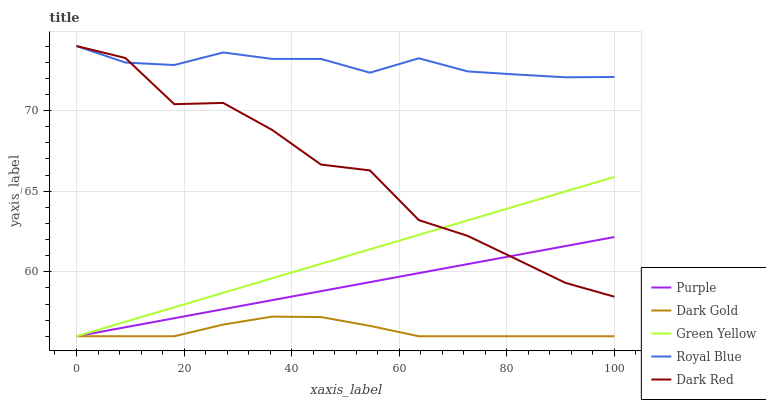Does Dark Gold have the minimum area under the curve?
Answer yes or no. Yes. Does Royal Blue have the maximum area under the curve?
Answer yes or no. Yes. Does Green Yellow have the minimum area under the curve?
Answer yes or no. No. Does Green Yellow have the maximum area under the curve?
Answer yes or no. No. Is Green Yellow the smoothest?
Answer yes or no. Yes. Is Dark Red the roughest?
Answer yes or no. Yes. Is Royal Blue the smoothest?
Answer yes or no. No. Is Royal Blue the roughest?
Answer yes or no. No. Does Purple have the lowest value?
Answer yes or no. Yes. Does Royal Blue have the lowest value?
Answer yes or no. No. Does Dark Red have the highest value?
Answer yes or no. Yes. Does Green Yellow have the highest value?
Answer yes or no. No. Is Dark Gold less than Royal Blue?
Answer yes or no. Yes. Is Dark Red greater than Dark Gold?
Answer yes or no. Yes. Does Royal Blue intersect Dark Red?
Answer yes or no. Yes. Is Royal Blue less than Dark Red?
Answer yes or no. No. Is Royal Blue greater than Dark Red?
Answer yes or no. No. Does Dark Gold intersect Royal Blue?
Answer yes or no. No. 